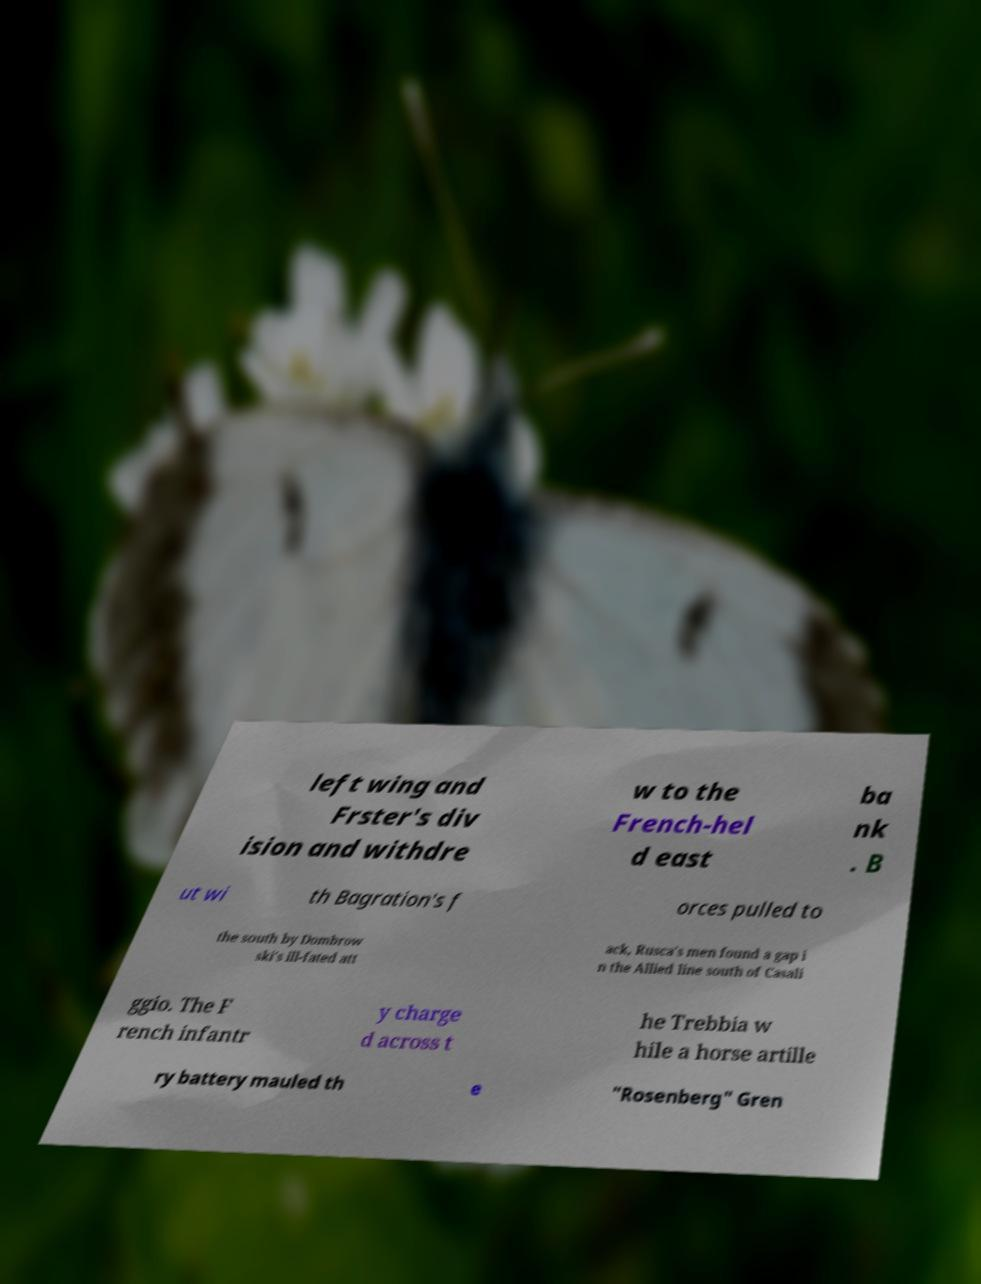For documentation purposes, I need the text within this image transcribed. Could you provide that? left wing and Frster's div ision and withdre w to the French-hel d east ba nk . B ut wi th Bagration's f orces pulled to the south by Dombrow ski's ill-fated att ack, Rusca's men found a gap i n the Allied line south of Casali ggio. The F rench infantr y charge d across t he Trebbia w hile a horse artille ry battery mauled th e "Rosenberg" Gren 